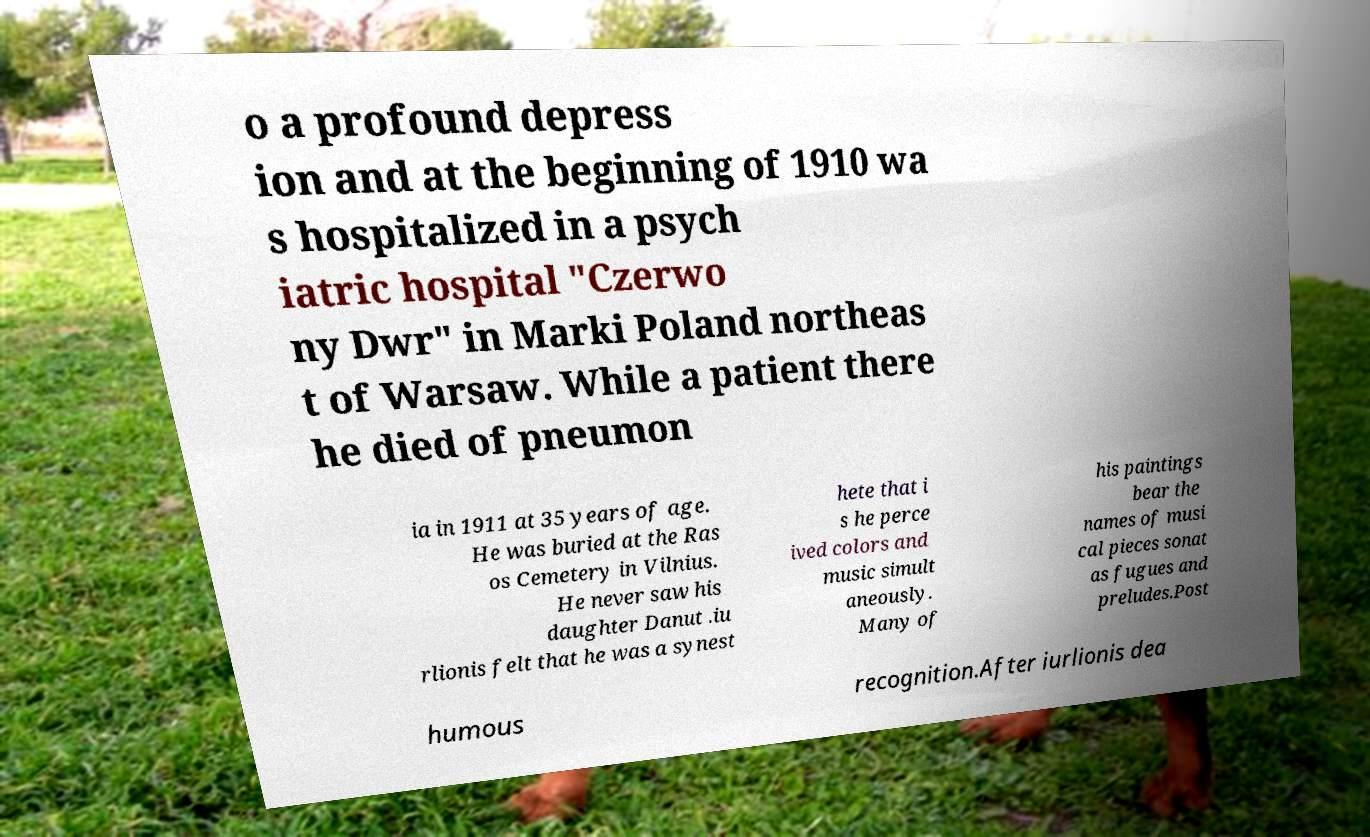There's text embedded in this image that I need extracted. Can you transcribe it verbatim? o a profound depress ion and at the beginning of 1910 wa s hospitalized in a psych iatric hospital "Czerwo ny Dwr" in Marki Poland northeas t of Warsaw. While a patient there he died of pneumon ia in 1911 at 35 years of age. He was buried at the Ras os Cemetery in Vilnius. He never saw his daughter Danut .iu rlionis felt that he was a synest hete that i s he perce ived colors and music simult aneously. Many of his paintings bear the names of musi cal pieces sonat as fugues and preludes.Post humous recognition.After iurlionis dea 